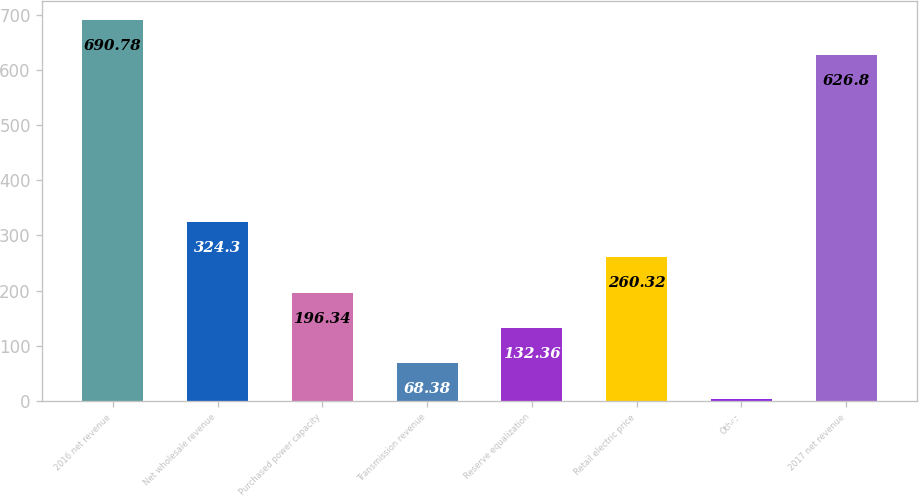<chart> <loc_0><loc_0><loc_500><loc_500><bar_chart><fcel>2016 net revenue<fcel>Net wholesale revenue<fcel>Purchased power capacity<fcel>Transmission revenue<fcel>Reserve equalization<fcel>Retail electric price<fcel>Other<fcel>2017 net revenue<nl><fcel>690.78<fcel>324.3<fcel>196.34<fcel>68.38<fcel>132.36<fcel>260.32<fcel>4.4<fcel>626.8<nl></chart> 